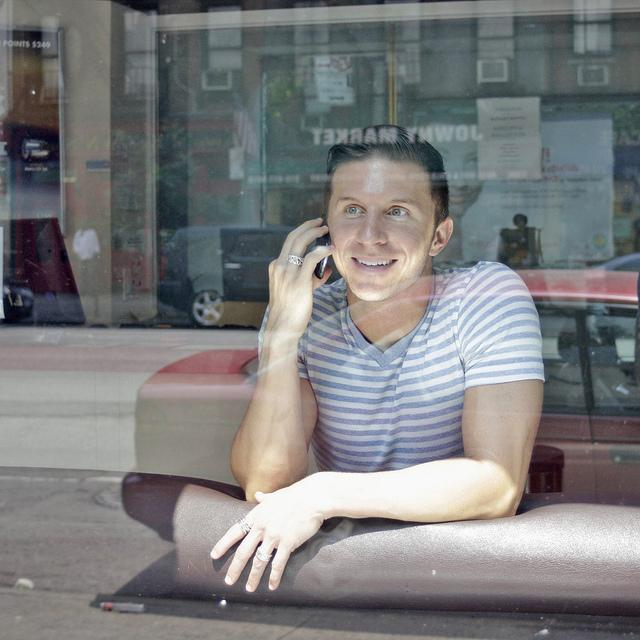What is the man on the phone sitting behind? Please explain your reasoning. glass. He is behind a window. 